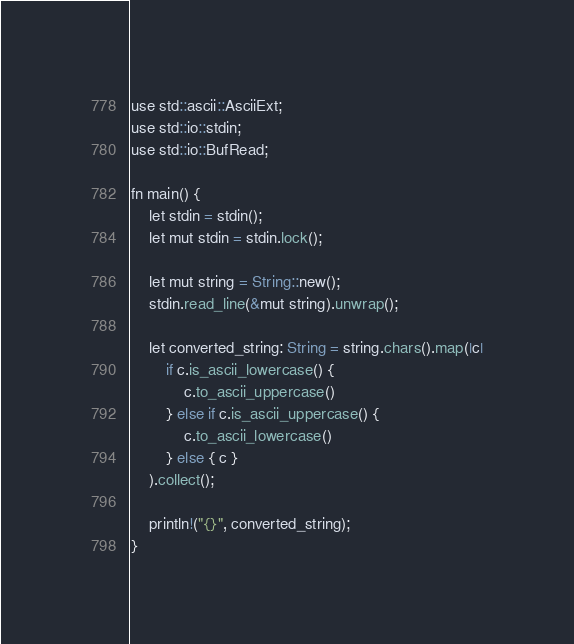Convert code to text. <code><loc_0><loc_0><loc_500><loc_500><_Kotlin_>use std::ascii::AsciiExt;
use std::io::stdin;
use std::io::BufRead;

fn main() {
    let stdin = stdin();
    let mut stdin = stdin.lock();

    let mut string = String::new();
    stdin.read_line(&mut string).unwrap();

    let converted_string: String = string.chars().map(|c|
        if c.is_ascii_lowercase() {
            c.to_ascii_uppercase()
        } else if c.is_ascii_uppercase() {
            c.to_ascii_lowercase()
        } else { c }
    ).collect();

    println!("{}", converted_string);
}
</code> 